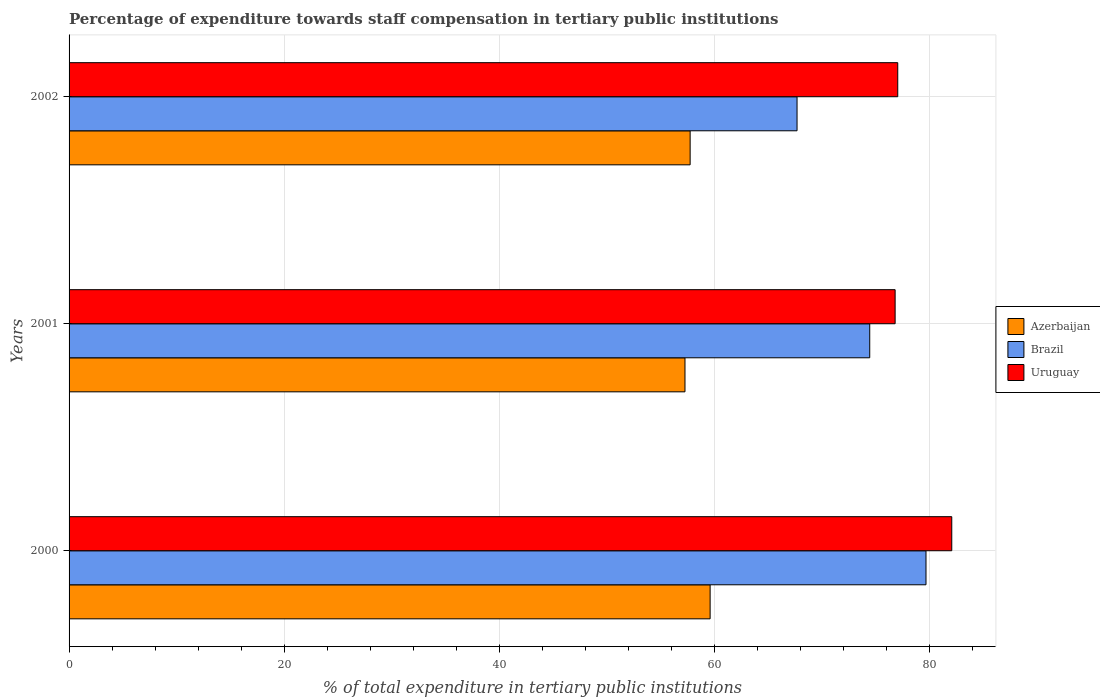How many groups of bars are there?
Your response must be concise. 3. Are the number of bars on each tick of the Y-axis equal?
Give a very brief answer. Yes. How many bars are there on the 1st tick from the bottom?
Your answer should be very brief. 3. In how many cases, is the number of bars for a given year not equal to the number of legend labels?
Your response must be concise. 0. What is the percentage of expenditure towards staff compensation in Uruguay in 2002?
Give a very brief answer. 77.05. Across all years, what is the maximum percentage of expenditure towards staff compensation in Uruguay?
Offer a very short reply. 82.07. Across all years, what is the minimum percentage of expenditure towards staff compensation in Uruguay?
Make the answer very short. 76.8. What is the total percentage of expenditure towards staff compensation in Brazil in the graph?
Offer a terse response. 221.8. What is the difference between the percentage of expenditure towards staff compensation in Uruguay in 2000 and that in 2001?
Give a very brief answer. 5.27. What is the difference between the percentage of expenditure towards staff compensation in Brazil in 2001 and the percentage of expenditure towards staff compensation in Azerbaijan in 2002?
Ensure brevity in your answer.  16.7. What is the average percentage of expenditure towards staff compensation in Brazil per year?
Give a very brief answer. 73.93. In the year 2002, what is the difference between the percentage of expenditure towards staff compensation in Brazil and percentage of expenditure towards staff compensation in Uruguay?
Your answer should be compact. -9.36. What is the ratio of the percentage of expenditure towards staff compensation in Brazil in 2000 to that in 2002?
Ensure brevity in your answer.  1.18. Is the difference between the percentage of expenditure towards staff compensation in Brazil in 2001 and 2002 greater than the difference between the percentage of expenditure towards staff compensation in Uruguay in 2001 and 2002?
Make the answer very short. Yes. What is the difference between the highest and the second highest percentage of expenditure towards staff compensation in Brazil?
Provide a short and direct response. 5.23. What is the difference between the highest and the lowest percentage of expenditure towards staff compensation in Uruguay?
Keep it short and to the point. 5.27. Is the sum of the percentage of expenditure towards staff compensation in Azerbaijan in 2000 and 2002 greater than the maximum percentage of expenditure towards staff compensation in Uruguay across all years?
Ensure brevity in your answer.  Yes. What does the 3rd bar from the top in 2000 represents?
Your answer should be compact. Azerbaijan. What does the 1st bar from the bottom in 2002 represents?
Your answer should be compact. Azerbaijan. Is it the case that in every year, the sum of the percentage of expenditure towards staff compensation in Uruguay and percentage of expenditure towards staff compensation in Azerbaijan is greater than the percentage of expenditure towards staff compensation in Brazil?
Make the answer very short. Yes. Does the graph contain grids?
Offer a terse response. Yes. How many legend labels are there?
Give a very brief answer. 3. How are the legend labels stacked?
Make the answer very short. Vertical. What is the title of the graph?
Your response must be concise. Percentage of expenditure towards staff compensation in tertiary public institutions. What is the label or title of the X-axis?
Keep it short and to the point. % of total expenditure in tertiary public institutions. What is the label or title of the Y-axis?
Give a very brief answer. Years. What is the % of total expenditure in tertiary public institutions in Azerbaijan in 2000?
Ensure brevity in your answer.  59.6. What is the % of total expenditure in tertiary public institutions of Brazil in 2000?
Provide a succinct answer. 79.67. What is the % of total expenditure in tertiary public institutions in Uruguay in 2000?
Give a very brief answer. 82.07. What is the % of total expenditure in tertiary public institutions in Azerbaijan in 2001?
Provide a succinct answer. 57.26. What is the % of total expenditure in tertiary public institutions of Brazil in 2001?
Your response must be concise. 74.44. What is the % of total expenditure in tertiary public institutions in Uruguay in 2001?
Provide a short and direct response. 76.8. What is the % of total expenditure in tertiary public institutions of Azerbaijan in 2002?
Ensure brevity in your answer.  57.74. What is the % of total expenditure in tertiary public institutions of Brazil in 2002?
Offer a terse response. 67.68. What is the % of total expenditure in tertiary public institutions of Uruguay in 2002?
Provide a succinct answer. 77.05. Across all years, what is the maximum % of total expenditure in tertiary public institutions of Azerbaijan?
Your response must be concise. 59.6. Across all years, what is the maximum % of total expenditure in tertiary public institutions of Brazil?
Give a very brief answer. 79.67. Across all years, what is the maximum % of total expenditure in tertiary public institutions of Uruguay?
Offer a very short reply. 82.07. Across all years, what is the minimum % of total expenditure in tertiary public institutions in Azerbaijan?
Keep it short and to the point. 57.26. Across all years, what is the minimum % of total expenditure in tertiary public institutions of Brazil?
Keep it short and to the point. 67.68. Across all years, what is the minimum % of total expenditure in tertiary public institutions of Uruguay?
Your answer should be very brief. 76.8. What is the total % of total expenditure in tertiary public institutions in Azerbaijan in the graph?
Offer a very short reply. 174.61. What is the total % of total expenditure in tertiary public institutions of Brazil in the graph?
Provide a succinct answer. 221.8. What is the total % of total expenditure in tertiary public institutions of Uruguay in the graph?
Make the answer very short. 235.92. What is the difference between the % of total expenditure in tertiary public institutions of Azerbaijan in 2000 and that in 2001?
Provide a short and direct response. 2.34. What is the difference between the % of total expenditure in tertiary public institutions in Brazil in 2000 and that in 2001?
Provide a short and direct response. 5.23. What is the difference between the % of total expenditure in tertiary public institutions in Uruguay in 2000 and that in 2001?
Offer a very short reply. 5.27. What is the difference between the % of total expenditure in tertiary public institutions of Azerbaijan in 2000 and that in 2002?
Offer a terse response. 1.86. What is the difference between the % of total expenditure in tertiary public institutions in Brazil in 2000 and that in 2002?
Offer a terse response. 11.99. What is the difference between the % of total expenditure in tertiary public institutions in Uruguay in 2000 and that in 2002?
Offer a terse response. 5.02. What is the difference between the % of total expenditure in tertiary public institutions of Azerbaijan in 2001 and that in 2002?
Offer a very short reply. -0.48. What is the difference between the % of total expenditure in tertiary public institutions of Brazil in 2001 and that in 2002?
Your response must be concise. 6.76. What is the difference between the % of total expenditure in tertiary public institutions in Uruguay in 2001 and that in 2002?
Your answer should be very brief. -0.24. What is the difference between the % of total expenditure in tertiary public institutions of Azerbaijan in 2000 and the % of total expenditure in tertiary public institutions of Brazil in 2001?
Your answer should be very brief. -14.84. What is the difference between the % of total expenditure in tertiary public institutions of Azerbaijan in 2000 and the % of total expenditure in tertiary public institutions of Uruguay in 2001?
Give a very brief answer. -17.2. What is the difference between the % of total expenditure in tertiary public institutions in Brazil in 2000 and the % of total expenditure in tertiary public institutions in Uruguay in 2001?
Keep it short and to the point. 2.87. What is the difference between the % of total expenditure in tertiary public institutions in Azerbaijan in 2000 and the % of total expenditure in tertiary public institutions in Brazil in 2002?
Offer a terse response. -8.08. What is the difference between the % of total expenditure in tertiary public institutions of Azerbaijan in 2000 and the % of total expenditure in tertiary public institutions of Uruguay in 2002?
Your answer should be very brief. -17.44. What is the difference between the % of total expenditure in tertiary public institutions of Brazil in 2000 and the % of total expenditure in tertiary public institutions of Uruguay in 2002?
Ensure brevity in your answer.  2.63. What is the difference between the % of total expenditure in tertiary public institutions of Azerbaijan in 2001 and the % of total expenditure in tertiary public institutions of Brazil in 2002?
Make the answer very short. -10.42. What is the difference between the % of total expenditure in tertiary public institutions of Azerbaijan in 2001 and the % of total expenditure in tertiary public institutions of Uruguay in 2002?
Your answer should be very brief. -19.78. What is the difference between the % of total expenditure in tertiary public institutions in Brazil in 2001 and the % of total expenditure in tertiary public institutions in Uruguay in 2002?
Make the answer very short. -2.61. What is the average % of total expenditure in tertiary public institutions of Azerbaijan per year?
Offer a very short reply. 58.2. What is the average % of total expenditure in tertiary public institutions of Brazil per year?
Your answer should be very brief. 73.93. What is the average % of total expenditure in tertiary public institutions of Uruguay per year?
Offer a terse response. 78.64. In the year 2000, what is the difference between the % of total expenditure in tertiary public institutions of Azerbaijan and % of total expenditure in tertiary public institutions of Brazil?
Make the answer very short. -20.07. In the year 2000, what is the difference between the % of total expenditure in tertiary public institutions in Azerbaijan and % of total expenditure in tertiary public institutions in Uruguay?
Make the answer very short. -22.47. In the year 2000, what is the difference between the % of total expenditure in tertiary public institutions in Brazil and % of total expenditure in tertiary public institutions in Uruguay?
Make the answer very short. -2.4. In the year 2001, what is the difference between the % of total expenditure in tertiary public institutions in Azerbaijan and % of total expenditure in tertiary public institutions in Brazil?
Keep it short and to the point. -17.18. In the year 2001, what is the difference between the % of total expenditure in tertiary public institutions in Azerbaijan and % of total expenditure in tertiary public institutions in Uruguay?
Keep it short and to the point. -19.54. In the year 2001, what is the difference between the % of total expenditure in tertiary public institutions in Brazil and % of total expenditure in tertiary public institutions in Uruguay?
Provide a succinct answer. -2.36. In the year 2002, what is the difference between the % of total expenditure in tertiary public institutions in Azerbaijan and % of total expenditure in tertiary public institutions in Brazil?
Your answer should be compact. -9.94. In the year 2002, what is the difference between the % of total expenditure in tertiary public institutions in Azerbaijan and % of total expenditure in tertiary public institutions in Uruguay?
Your response must be concise. -19.3. In the year 2002, what is the difference between the % of total expenditure in tertiary public institutions in Brazil and % of total expenditure in tertiary public institutions in Uruguay?
Provide a short and direct response. -9.36. What is the ratio of the % of total expenditure in tertiary public institutions in Azerbaijan in 2000 to that in 2001?
Offer a terse response. 1.04. What is the ratio of the % of total expenditure in tertiary public institutions in Brazil in 2000 to that in 2001?
Ensure brevity in your answer.  1.07. What is the ratio of the % of total expenditure in tertiary public institutions in Uruguay in 2000 to that in 2001?
Provide a succinct answer. 1.07. What is the ratio of the % of total expenditure in tertiary public institutions in Azerbaijan in 2000 to that in 2002?
Give a very brief answer. 1.03. What is the ratio of the % of total expenditure in tertiary public institutions in Brazil in 2000 to that in 2002?
Provide a short and direct response. 1.18. What is the ratio of the % of total expenditure in tertiary public institutions in Uruguay in 2000 to that in 2002?
Your answer should be very brief. 1.07. What is the ratio of the % of total expenditure in tertiary public institutions in Azerbaijan in 2001 to that in 2002?
Give a very brief answer. 0.99. What is the ratio of the % of total expenditure in tertiary public institutions in Brazil in 2001 to that in 2002?
Make the answer very short. 1.1. What is the difference between the highest and the second highest % of total expenditure in tertiary public institutions in Azerbaijan?
Provide a succinct answer. 1.86. What is the difference between the highest and the second highest % of total expenditure in tertiary public institutions of Brazil?
Offer a very short reply. 5.23. What is the difference between the highest and the second highest % of total expenditure in tertiary public institutions in Uruguay?
Make the answer very short. 5.02. What is the difference between the highest and the lowest % of total expenditure in tertiary public institutions in Azerbaijan?
Offer a terse response. 2.34. What is the difference between the highest and the lowest % of total expenditure in tertiary public institutions of Brazil?
Your response must be concise. 11.99. What is the difference between the highest and the lowest % of total expenditure in tertiary public institutions in Uruguay?
Your answer should be very brief. 5.27. 